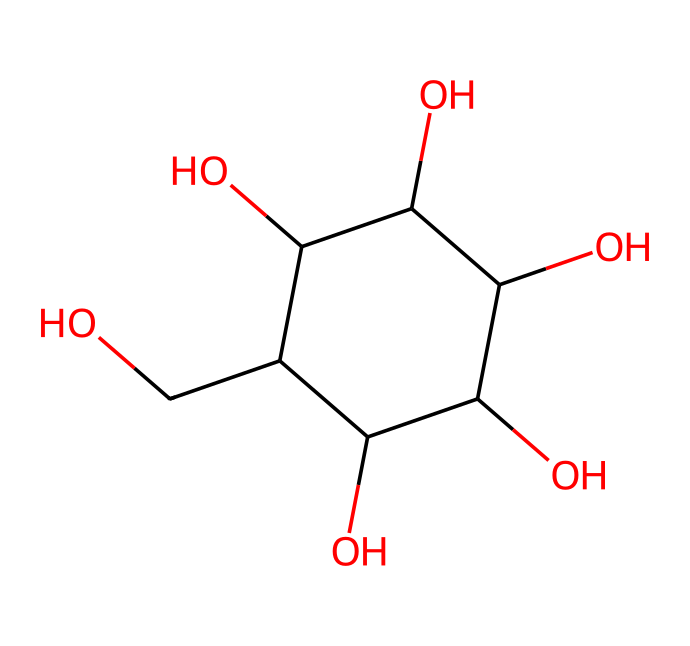What is the molecular formula of this structure? The molecular formula can be deduced by counting the number of carbon (C), hydrogen (H), and oxygen (O) atoms in the structure. In this case, there are 6 carbon atoms, 12 hydrogen atoms, and 6 oxygen atoms, resulting in the formula C6H12O6.
Answer: C6H12O6 How many hydroxyl (–OH) groups does this molecule contain? By examining the structure, we can identify the –OH groups. In this case, there are 5 distinct –OH groups present, which are commonly found in sugar molecules to contribute to their solubility and reactivity.
Answer: 5 Is this molecule a monosaccharide, disaccharide, or polysaccharide? The structure of the molecule shows that it consists of a single sugar unit with no glycosidic bonds linking to other sugar units. Thus, it is classified as a monosaccharide.
Answer: monosaccharide How many rings are present in this chemical structure? The chemical structure shows one cyclic part, which indicates that it forms a single ring structure, characteristic of many carbohydrates, including sugars.
Answer: 1 What type of carbohydrate is represented by this structure? Given the specific arrangement and the number of hydroxyl groups and carbon atoms, this molecule is identified as an aldose, specifically glucose, which is a common type of simple sugar (monosaccharide).
Answer: aldose 